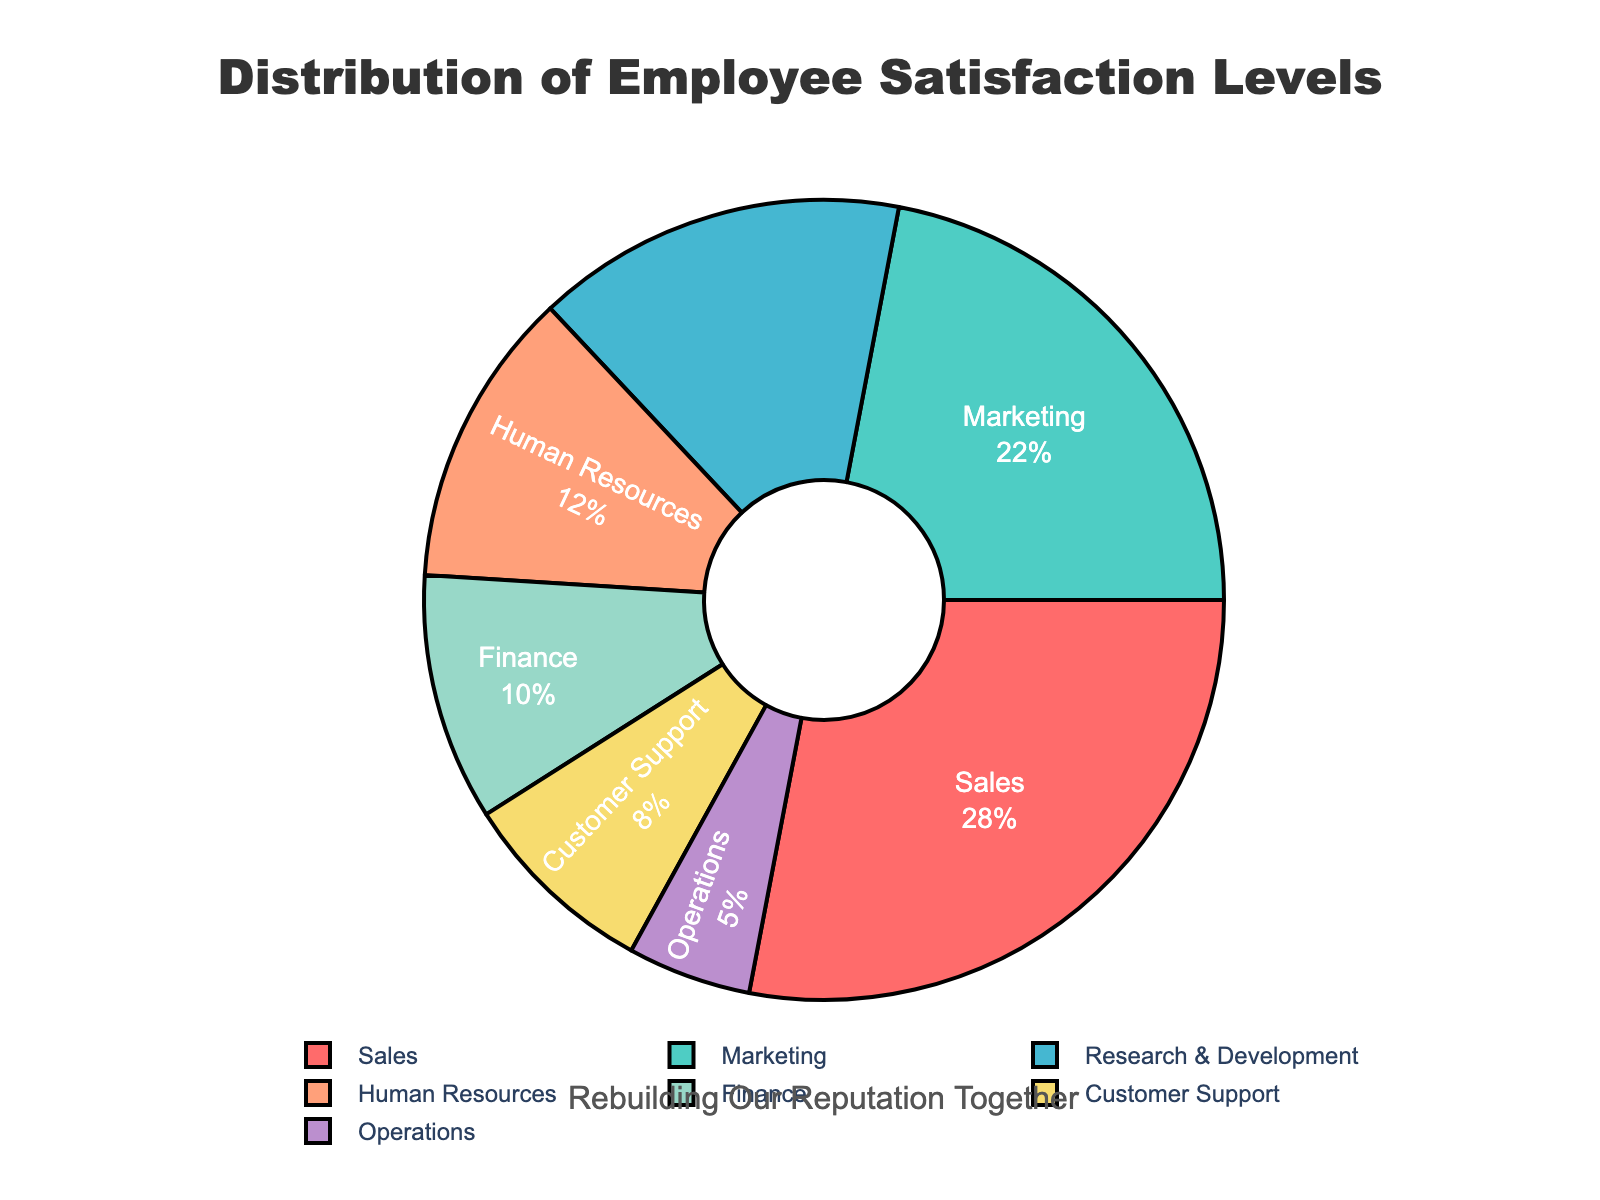What percentage of employees in the Sales department are very satisfied? The Sales department is marked on the pie chart, and the label indicates that 28% of employees in Sales are very satisfied.
Answer: 28% How does the percentage of very satisfied employees in Human Resources compare to those in Sales? The chart shows that 12% of employees in Human Resources are very satisfied, while 28% of employees in Sales are very satisfied. To compare, 28% is more than 12%.
Answer: Sales has 16% more very satisfied employees than Human Resources Which department has the smallest percentage of employees who are neutral? The pie chart indicates that the Operations department has a neutral satisfaction level of 5%, which is the smallest among the departments listed.
Answer: Operations What is the combined percentage of employees in Marketing and Finance who are satisfied? The Marketing department has 22% satisfied employees, and the Finance department has 10% satisfied employees. Adding these together gives 22% + 10% = 32%.
Answer: 32% How many percentage points higher is the satisfaction level in Customer Support compared to Operations? Customer Support has 8% dissatisfied employees, while Operations has 5% neutral employees. The difference is 8% - 5%, which is 3% higher.
Answer: 3% What is the predominant satisfaction level in the Research & Development department? The pie chart shows that 15% of employees in Research & Development are neutral, indicating that neutral is the predominant satisfaction level for this department.
Answer: Neutral Which department has more satisfied employees, Marketing or Finance? The pie chart shows that Marketing has 22% satisfied employees, while Finance has 10% satisfied employees. Therefore, Marketing has more satisfied employees.
Answer: Marketing What is the color assigned to the Sales department in the pie chart? On the pie chart, the Sales department is represented by a section colored in red.
Answer: Red If we combine very satisfied employees from Sales and Human Resources, what percentage do we get? The Sales department has 28% very satisfied employees, and Human Resources has 12% very satisfied employees. Adding these together gives 28% + 12% = 40%.
Answer: 40% Which department has the highest level of employee dissatisfaction, and what is this percentage? The pie chart indicates that the Customer Support department has the highest dissatisfaction level at 8%.
Answer: Customer Support with 8% 